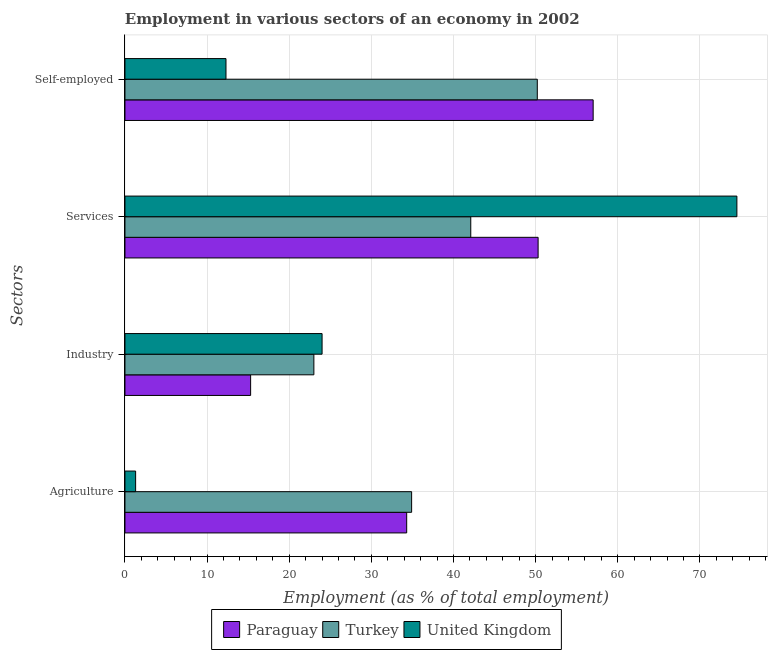How many different coloured bars are there?
Provide a short and direct response. 3. How many groups of bars are there?
Give a very brief answer. 4. Are the number of bars per tick equal to the number of legend labels?
Give a very brief answer. Yes. How many bars are there on the 4th tick from the top?
Offer a very short reply. 3. How many bars are there on the 3rd tick from the bottom?
Offer a terse response. 3. What is the label of the 1st group of bars from the top?
Your answer should be compact. Self-employed. What is the percentage of self employed workers in United Kingdom?
Provide a succinct answer. 12.3. Across all countries, what is the maximum percentage of workers in services?
Provide a succinct answer. 74.5. Across all countries, what is the minimum percentage of workers in agriculture?
Offer a very short reply. 1.3. What is the total percentage of self employed workers in the graph?
Your answer should be very brief. 119.5. What is the difference between the percentage of self employed workers in Paraguay and that in Turkey?
Provide a succinct answer. 6.8. What is the difference between the percentage of workers in industry in Paraguay and the percentage of workers in agriculture in United Kingdom?
Your answer should be very brief. 14. What is the average percentage of workers in industry per country?
Provide a succinct answer. 20.77. What is the difference between the percentage of self employed workers and percentage of workers in industry in Paraguay?
Your answer should be compact. 41.7. What is the ratio of the percentage of workers in services in Turkey to that in Paraguay?
Provide a short and direct response. 0.84. Is the difference between the percentage of workers in services in Paraguay and United Kingdom greater than the difference between the percentage of workers in agriculture in Paraguay and United Kingdom?
Offer a very short reply. No. What is the difference between the highest and the second highest percentage of self employed workers?
Make the answer very short. 6.8. What is the difference between the highest and the lowest percentage of self employed workers?
Keep it short and to the point. 44.7. Is the sum of the percentage of workers in services in Paraguay and Turkey greater than the maximum percentage of self employed workers across all countries?
Ensure brevity in your answer.  Yes. How many bars are there?
Your answer should be very brief. 12. How many countries are there in the graph?
Keep it short and to the point. 3. Does the graph contain any zero values?
Your answer should be very brief. No. Where does the legend appear in the graph?
Provide a succinct answer. Bottom center. How many legend labels are there?
Your response must be concise. 3. How are the legend labels stacked?
Offer a very short reply. Horizontal. What is the title of the graph?
Ensure brevity in your answer.  Employment in various sectors of an economy in 2002. What is the label or title of the X-axis?
Your response must be concise. Employment (as % of total employment). What is the label or title of the Y-axis?
Keep it short and to the point. Sectors. What is the Employment (as % of total employment) of Paraguay in Agriculture?
Offer a very short reply. 34.3. What is the Employment (as % of total employment) of Turkey in Agriculture?
Offer a very short reply. 34.9. What is the Employment (as % of total employment) of United Kingdom in Agriculture?
Ensure brevity in your answer.  1.3. What is the Employment (as % of total employment) in Paraguay in Industry?
Your response must be concise. 15.3. What is the Employment (as % of total employment) in Turkey in Industry?
Make the answer very short. 23. What is the Employment (as % of total employment) in United Kingdom in Industry?
Offer a terse response. 24. What is the Employment (as % of total employment) of Paraguay in Services?
Give a very brief answer. 50.3. What is the Employment (as % of total employment) of Turkey in Services?
Ensure brevity in your answer.  42.1. What is the Employment (as % of total employment) of United Kingdom in Services?
Ensure brevity in your answer.  74.5. What is the Employment (as % of total employment) in Paraguay in Self-employed?
Offer a very short reply. 57. What is the Employment (as % of total employment) of Turkey in Self-employed?
Your response must be concise. 50.2. What is the Employment (as % of total employment) in United Kingdom in Self-employed?
Your answer should be very brief. 12.3. Across all Sectors, what is the maximum Employment (as % of total employment) of Paraguay?
Provide a short and direct response. 57. Across all Sectors, what is the maximum Employment (as % of total employment) of Turkey?
Give a very brief answer. 50.2. Across all Sectors, what is the maximum Employment (as % of total employment) in United Kingdom?
Offer a terse response. 74.5. Across all Sectors, what is the minimum Employment (as % of total employment) of Paraguay?
Keep it short and to the point. 15.3. Across all Sectors, what is the minimum Employment (as % of total employment) in United Kingdom?
Provide a succinct answer. 1.3. What is the total Employment (as % of total employment) of Paraguay in the graph?
Offer a terse response. 156.9. What is the total Employment (as % of total employment) in Turkey in the graph?
Keep it short and to the point. 150.2. What is the total Employment (as % of total employment) of United Kingdom in the graph?
Keep it short and to the point. 112.1. What is the difference between the Employment (as % of total employment) in Paraguay in Agriculture and that in Industry?
Provide a succinct answer. 19. What is the difference between the Employment (as % of total employment) in Turkey in Agriculture and that in Industry?
Offer a terse response. 11.9. What is the difference between the Employment (as % of total employment) of United Kingdom in Agriculture and that in Industry?
Provide a short and direct response. -22.7. What is the difference between the Employment (as % of total employment) of Turkey in Agriculture and that in Services?
Give a very brief answer. -7.2. What is the difference between the Employment (as % of total employment) in United Kingdom in Agriculture and that in Services?
Provide a short and direct response. -73.2. What is the difference between the Employment (as % of total employment) in Paraguay in Agriculture and that in Self-employed?
Your answer should be very brief. -22.7. What is the difference between the Employment (as % of total employment) of Turkey in Agriculture and that in Self-employed?
Keep it short and to the point. -15.3. What is the difference between the Employment (as % of total employment) of United Kingdom in Agriculture and that in Self-employed?
Ensure brevity in your answer.  -11. What is the difference between the Employment (as % of total employment) of Paraguay in Industry and that in Services?
Make the answer very short. -35. What is the difference between the Employment (as % of total employment) in Turkey in Industry and that in Services?
Give a very brief answer. -19.1. What is the difference between the Employment (as % of total employment) of United Kingdom in Industry and that in Services?
Your answer should be very brief. -50.5. What is the difference between the Employment (as % of total employment) of Paraguay in Industry and that in Self-employed?
Provide a succinct answer. -41.7. What is the difference between the Employment (as % of total employment) of Turkey in Industry and that in Self-employed?
Give a very brief answer. -27.2. What is the difference between the Employment (as % of total employment) in Turkey in Services and that in Self-employed?
Your answer should be compact. -8.1. What is the difference between the Employment (as % of total employment) of United Kingdom in Services and that in Self-employed?
Offer a terse response. 62.2. What is the difference between the Employment (as % of total employment) of Turkey in Agriculture and the Employment (as % of total employment) of United Kingdom in Industry?
Give a very brief answer. 10.9. What is the difference between the Employment (as % of total employment) of Paraguay in Agriculture and the Employment (as % of total employment) of Turkey in Services?
Offer a very short reply. -7.8. What is the difference between the Employment (as % of total employment) in Paraguay in Agriculture and the Employment (as % of total employment) in United Kingdom in Services?
Give a very brief answer. -40.2. What is the difference between the Employment (as % of total employment) in Turkey in Agriculture and the Employment (as % of total employment) in United Kingdom in Services?
Offer a terse response. -39.6. What is the difference between the Employment (as % of total employment) of Paraguay in Agriculture and the Employment (as % of total employment) of Turkey in Self-employed?
Make the answer very short. -15.9. What is the difference between the Employment (as % of total employment) of Turkey in Agriculture and the Employment (as % of total employment) of United Kingdom in Self-employed?
Your response must be concise. 22.6. What is the difference between the Employment (as % of total employment) in Paraguay in Industry and the Employment (as % of total employment) in Turkey in Services?
Your response must be concise. -26.8. What is the difference between the Employment (as % of total employment) of Paraguay in Industry and the Employment (as % of total employment) of United Kingdom in Services?
Ensure brevity in your answer.  -59.2. What is the difference between the Employment (as % of total employment) in Turkey in Industry and the Employment (as % of total employment) in United Kingdom in Services?
Your answer should be compact. -51.5. What is the difference between the Employment (as % of total employment) in Paraguay in Industry and the Employment (as % of total employment) in Turkey in Self-employed?
Keep it short and to the point. -34.9. What is the difference between the Employment (as % of total employment) of Paraguay in Industry and the Employment (as % of total employment) of United Kingdom in Self-employed?
Keep it short and to the point. 3. What is the difference between the Employment (as % of total employment) in Paraguay in Services and the Employment (as % of total employment) in Turkey in Self-employed?
Make the answer very short. 0.1. What is the difference between the Employment (as % of total employment) of Turkey in Services and the Employment (as % of total employment) of United Kingdom in Self-employed?
Offer a terse response. 29.8. What is the average Employment (as % of total employment) in Paraguay per Sectors?
Make the answer very short. 39.23. What is the average Employment (as % of total employment) of Turkey per Sectors?
Give a very brief answer. 37.55. What is the average Employment (as % of total employment) of United Kingdom per Sectors?
Give a very brief answer. 28.02. What is the difference between the Employment (as % of total employment) in Turkey and Employment (as % of total employment) in United Kingdom in Agriculture?
Give a very brief answer. 33.6. What is the difference between the Employment (as % of total employment) in Turkey and Employment (as % of total employment) in United Kingdom in Industry?
Keep it short and to the point. -1. What is the difference between the Employment (as % of total employment) of Paraguay and Employment (as % of total employment) of United Kingdom in Services?
Keep it short and to the point. -24.2. What is the difference between the Employment (as % of total employment) in Turkey and Employment (as % of total employment) in United Kingdom in Services?
Your answer should be very brief. -32.4. What is the difference between the Employment (as % of total employment) of Paraguay and Employment (as % of total employment) of Turkey in Self-employed?
Your answer should be compact. 6.8. What is the difference between the Employment (as % of total employment) in Paraguay and Employment (as % of total employment) in United Kingdom in Self-employed?
Give a very brief answer. 44.7. What is the difference between the Employment (as % of total employment) in Turkey and Employment (as % of total employment) in United Kingdom in Self-employed?
Offer a terse response. 37.9. What is the ratio of the Employment (as % of total employment) of Paraguay in Agriculture to that in Industry?
Your answer should be compact. 2.24. What is the ratio of the Employment (as % of total employment) in Turkey in Agriculture to that in Industry?
Your answer should be compact. 1.52. What is the ratio of the Employment (as % of total employment) of United Kingdom in Agriculture to that in Industry?
Provide a short and direct response. 0.05. What is the ratio of the Employment (as % of total employment) in Paraguay in Agriculture to that in Services?
Make the answer very short. 0.68. What is the ratio of the Employment (as % of total employment) in Turkey in Agriculture to that in Services?
Your response must be concise. 0.83. What is the ratio of the Employment (as % of total employment) of United Kingdom in Agriculture to that in Services?
Ensure brevity in your answer.  0.02. What is the ratio of the Employment (as % of total employment) of Paraguay in Agriculture to that in Self-employed?
Give a very brief answer. 0.6. What is the ratio of the Employment (as % of total employment) of Turkey in Agriculture to that in Self-employed?
Offer a very short reply. 0.7. What is the ratio of the Employment (as % of total employment) of United Kingdom in Agriculture to that in Self-employed?
Make the answer very short. 0.11. What is the ratio of the Employment (as % of total employment) of Paraguay in Industry to that in Services?
Your response must be concise. 0.3. What is the ratio of the Employment (as % of total employment) in Turkey in Industry to that in Services?
Offer a terse response. 0.55. What is the ratio of the Employment (as % of total employment) in United Kingdom in Industry to that in Services?
Give a very brief answer. 0.32. What is the ratio of the Employment (as % of total employment) of Paraguay in Industry to that in Self-employed?
Your answer should be compact. 0.27. What is the ratio of the Employment (as % of total employment) of Turkey in Industry to that in Self-employed?
Offer a very short reply. 0.46. What is the ratio of the Employment (as % of total employment) of United Kingdom in Industry to that in Self-employed?
Your answer should be very brief. 1.95. What is the ratio of the Employment (as % of total employment) in Paraguay in Services to that in Self-employed?
Keep it short and to the point. 0.88. What is the ratio of the Employment (as % of total employment) of Turkey in Services to that in Self-employed?
Ensure brevity in your answer.  0.84. What is the ratio of the Employment (as % of total employment) in United Kingdom in Services to that in Self-employed?
Ensure brevity in your answer.  6.06. What is the difference between the highest and the second highest Employment (as % of total employment) of United Kingdom?
Ensure brevity in your answer.  50.5. What is the difference between the highest and the lowest Employment (as % of total employment) of Paraguay?
Offer a very short reply. 41.7. What is the difference between the highest and the lowest Employment (as % of total employment) in Turkey?
Provide a succinct answer. 27.2. What is the difference between the highest and the lowest Employment (as % of total employment) in United Kingdom?
Provide a succinct answer. 73.2. 